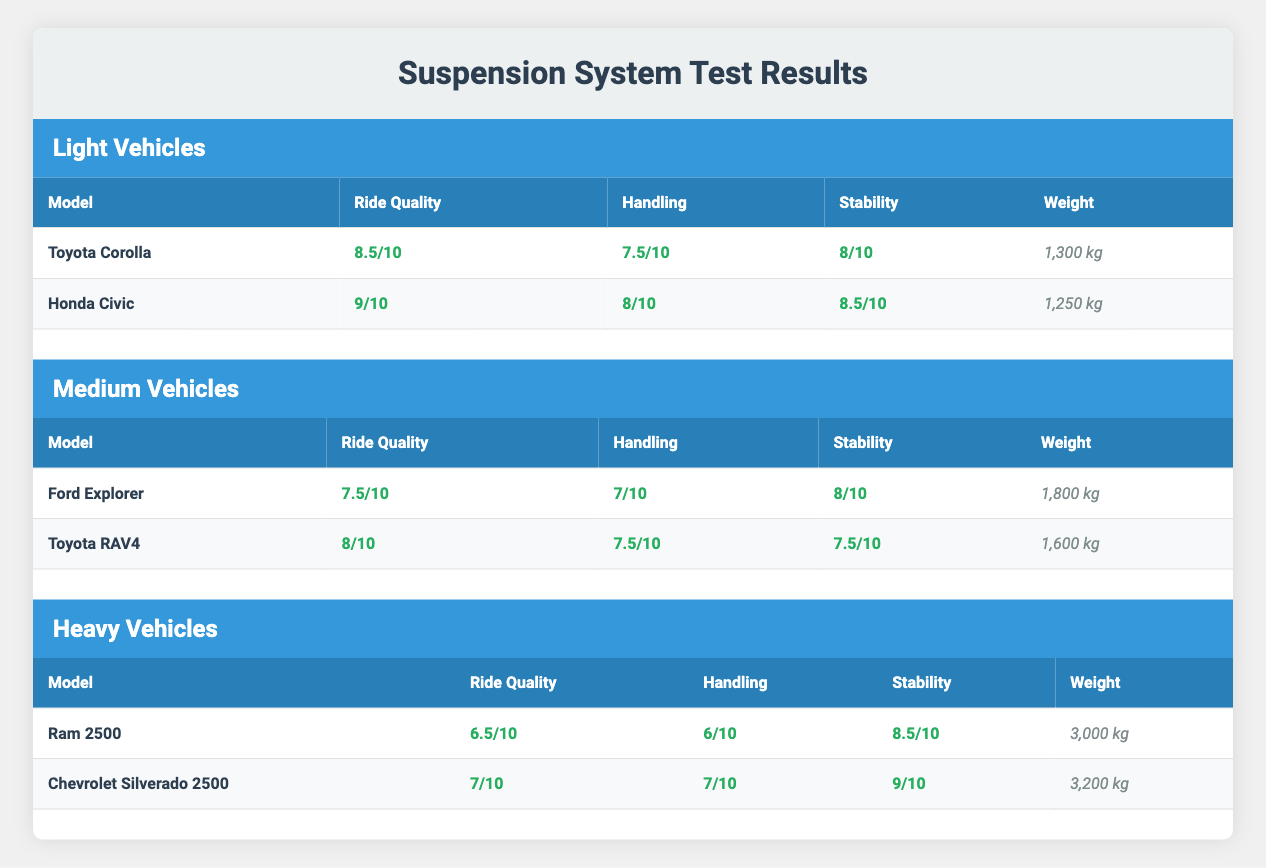What is the ride quality score of the Honda Civic? The table lists Honda Civic's ride quality score in the Light Vehicles section. It is explicitly mentioned as 9/10.
Answer: 9/10 Which vehicle has the highest stability score among Light Vehicles? In the Light Vehicles section, the stability scores for Toyota Corolla and Honda Civic are 8/10 and 8.5/10, respectively. Comparing these, Honda Civic has the highest stability score of 8.5/10.
Answer: 8.5/10 Is the Ford Explorer heavier than the Toyota RAV4? The weight of Ford Explorer is 1,800 kg, while Toyota RAV4 weighs 1,600 kg. Since 1,800 kg is greater than 1,600 kg, Ford Explorer is heavier.
Answer: Yes What is the difference in ride quality between the Ram 2500 and Chevrolet Silverado 2500? The ride quality score of Ram 2500 is 6.5/10 and that of Chevrolet Silverado 2500 is 7/10. The difference is calculated as 7 - 6.5 = 0.5.
Answer: 0.5 Which vehicle has the best handling score among all the vehicles listed? The handling scores are 9/10 for Honda Civic, 8/10 for Toyota Corolla, 7.5/10 for Toyota RAV4, 7/10 for Ford Explorer, 7/10 for Chevrolet Silverado 2500, and 6/10 for Ram 2500. The highest score is Honda Civic's 9/10.
Answer: Honda Civic What is the average ride quality score of the Medium Vehicles? The ride quality scores for Medium Vehicles are 7.5/10 for Ford Explorer and 8/10 for Toyota RAV4. To find the average: (7.5 + 8) / 2 = 7.75.
Answer: 7.75 Are all the Heavy Vehicles rated below 8 for ride quality? Ram 2500 has a ride quality of 6.5/10 and Chevrolet Silverado 2500 has 7/10, both are below 8. Thus, it is true that all Heavy Vehicles are rated below 8 for ride quality.
Answer: Yes What is the stability score of the Toyota RAV4? The table indicates that the stability score for Toyota RAV4 is 7.5/10 listed in the Medium Vehicles section.
Answer: 7.5/10 Which vehicle has the lowest handling score, and what is that score? The handling score of Ram 2500 is 6/10, which is lower than other vehicles when compared. Therefore, Ram 2500 has the lowest handling score of all the listed vehicles.
Answer: 6/10 